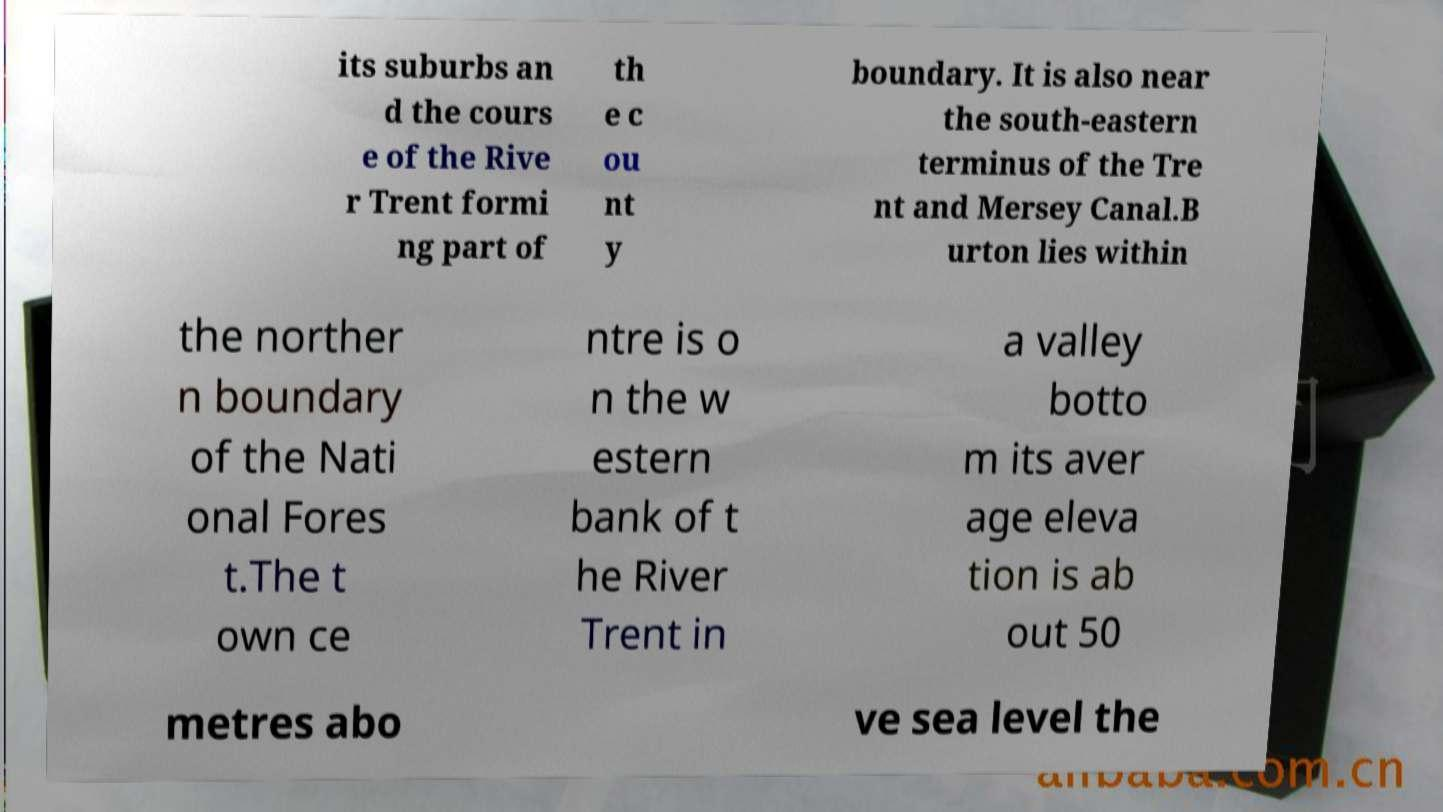There's text embedded in this image that I need extracted. Can you transcribe it verbatim? its suburbs an d the cours e of the Rive r Trent formi ng part of th e c ou nt y boundary. It is also near the south-eastern terminus of the Tre nt and Mersey Canal.B urton lies within the norther n boundary of the Nati onal Fores t.The t own ce ntre is o n the w estern bank of t he River Trent in a valley botto m its aver age eleva tion is ab out 50 metres abo ve sea level the 